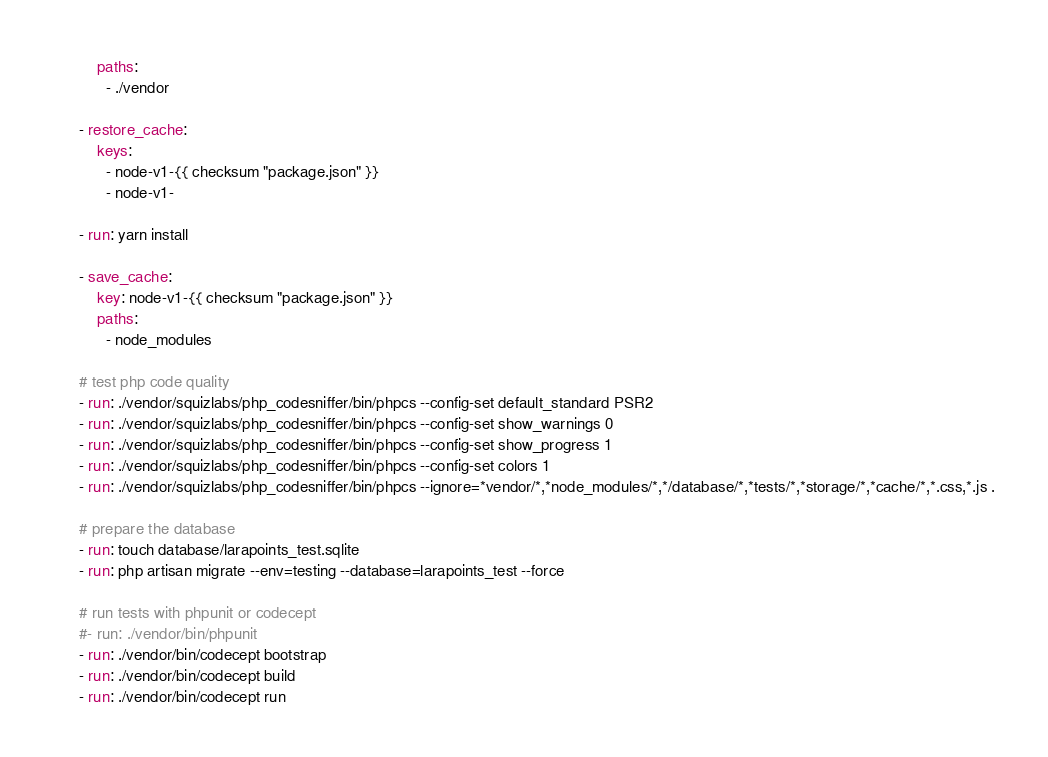<code> <loc_0><loc_0><loc_500><loc_500><_YAML_>          paths:
            - ./vendor

      - restore_cache:
          keys:
            - node-v1-{{ checksum "package.json" }}
            - node-v1-

      - run: yarn install

      - save_cache:
          key: node-v1-{{ checksum "package.json" }}
          paths:
            - node_modules

      # test php code quality
      - run: ./vendor/squizlabs/php_codesniffer/bin/phpcs --config-set default_standard PSR2
      - run: ./vendor/squizlabs/php_codesniffer/bin/phpcs --config-set show_warnings 0
      - run: ./vendor/squizlabs/php_codesniffer/bin/phpcs --config-set show_progress 1
      - run: ./vendor/squizlabs/php_codesniffer/bin/phpcs --config-set colors 1
      - run: ./vendor/squizlabs/php_codesniffer/bin/phpcs --ignore=*vendor/*,*node_modules/*,*/database/*,*tests/*,*storage/*,*cache/*,*.css,*.js .

      # prepare the database
      - run: touch database/larapoints_test.sqlite
      - run: php artisan migrate --env=testing --database=larapoints_test --force

      # run tests with phpunit or codecept
      #- run: ./vendor/bin/phpunit
      - run: ./vendor/bin/codecept bootstrap
      - run: ./vendor/bin/codecept build
      - run: ./vendor/bin/codecept run</code> 